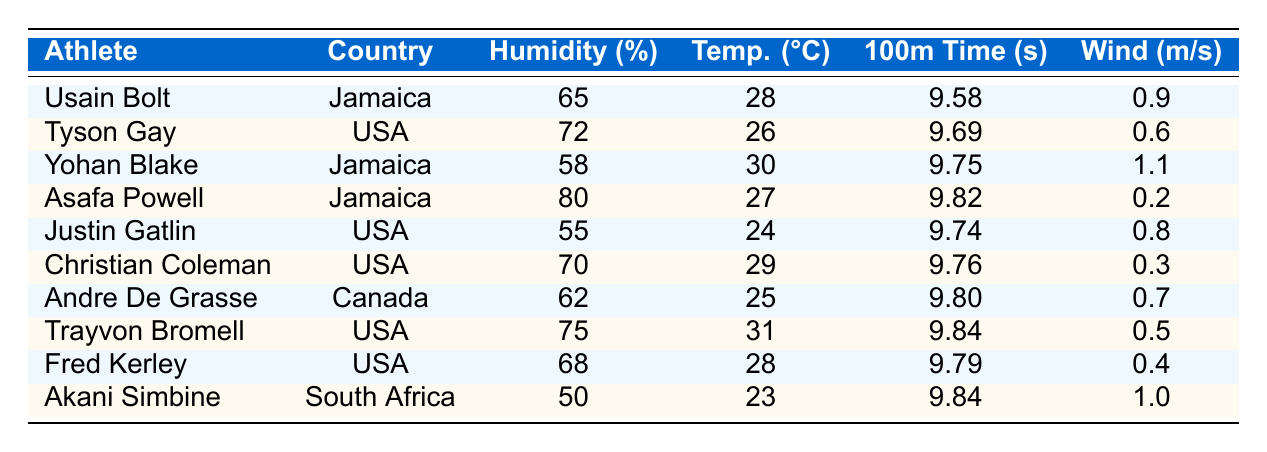What is the humidity level for Usain Bolt? In the table, Usain Bolt's record shows a humidity level of 65%.
Answer: 65% Which athlete has the highest humidity level? Asafa Powell has the highest humidity level listed in the table at 80%.
Answer: Asafa Powell What is the average time recorded for the 100m dash across all athletes? To find the average, sum all the 100m times: (9.58 + 9.69 + 9.75 + 9.82 + 9.74 + 9.76 + 9.80 + 9.84 + 9.79 + 9.84) = 97.60 seconds. Divide this by 10 (number of athletes) gives 97.60 / 10 = 9.76 seconds.
Answer: 9.76 seconds Is the statement "Humidity above 70% results in slower sprinting times" true based on this data? Examine the athletes with humidity above 70%: Tyson Gay (9.69s), Asafa Powell (9.82s), and Trayvon Bromell (9.84s). All these times are slower than Usain Bolt’s 9.58s at 65% humidity, supporting the idea that higher humidity correlates with slower times.
Answer: True What is the difference in 100m times between the athlete with the highest humidity and the athlete with the lowest? Asafa Powell (highest humidity at 80%) has a time of 9.82 seconds, and Akani Simbine (lowest humidity at 50%) has a time of 9.84 seconds. The difference is 9.84 - 9.82 = 0.02 seconds.
Answer: 0.02 seconds Which country has the athlete with the fastest time, and what is that time? The fastest time is recorded by Usain Bolt from Jamaica at 9.58 seconds.
Answer: Jamaica, 9.58 seconds How many athletes recorded times faster than 9.75 seconds? Review the times: Only Usain Bolt (9.58s) and Tyson Gay (9.69s) are faster than 9.75 seconds. Thus, there are 2 athletes.
Answer: 2 athletes What humidity level did Yohan Blake achieve? Yohan Blake’s associated humidity level in the table is 58%.
Answer: 58% Is there a correlation observed between humidity levels and the 100m dash times based on this data? A visual inspection of the table shows a trend that as humidity increases, the 100m times generally also increase (slower times). This suggests that higher humidity levels may correlate with slower sprinting times.
Answer: Yes, a correlation is observed 